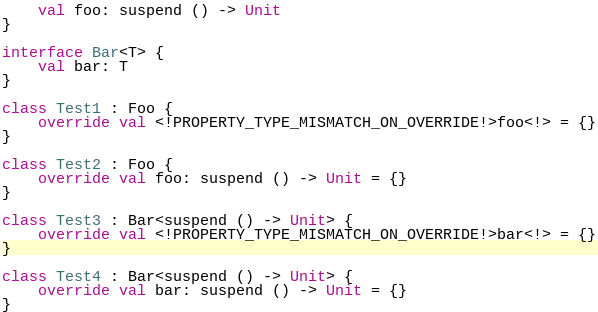<code> <loc_0><loc_0><loc_500><loc_500><_Kotlin_>    val foo: suspend () -> Unit
}

interface Bar<T> {
    val bar: T
}

class Test1 : Foo {
    override val <!PROPERTY_TYPE_MISMATCH_ON_OVERRIDE!>foo<!> = {}
}

class Test2 : Foo {
    override val foo: suspend () -> Unit = {}
}

class Test3 : Bar<suspend () -> Unit> {
    override val <!PROPERTY_TYPE_MISMATCH_ON_OVERRIDE!>bar<!> = {}
}

class Test4 : Bar<suspend () -> Unit> {
    override val bar: suspend () -> Unit = {}
}</code> 